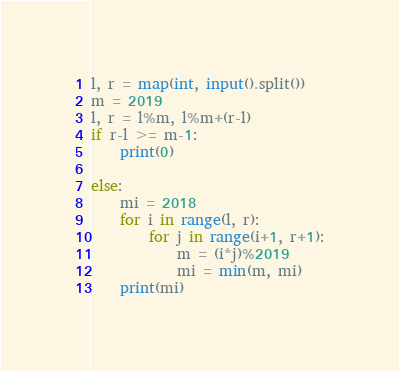Convert code to text. <code><loc_0><loc_0><loc_500><loc_500><_Python_>l, r = map(int, input().split())
m = 2019
l, r = l%m, l%m+(r-l)
if r-l >= m-1:
    print(0)

else:
    mi = 2018
    for i in range(l, r):
        for j in range(i+1, r+1):
            m = (i*j)%2019
            mi = min(m, mi)
    print(mi)
</code> 